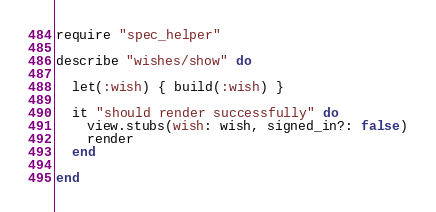Convert code to text. <code><loc_0><loc_0><loc_500><loc_500><_Ruby_>require "spec_helper"

describe "wishes/show" do

  let(:wish) { build(:wish) }

  it "should render successfully" do
    view.stubs(wish: wish, signed_in?: false)
    render
  end

end
</code> 